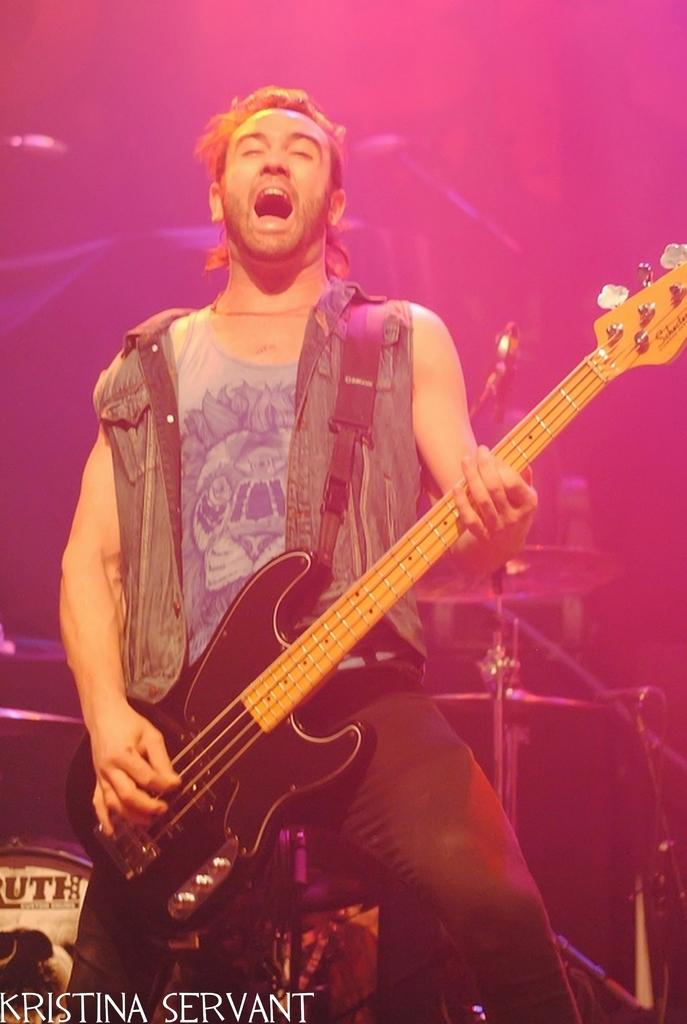What is the main subject in the foreground of the image? There is a man in the foreground of the image. What is the man doing in the image? The man is standing and playing a guitar. What can be seen in the background of the image? In the background, there is pink light, drums, and mic stands. What type of flesh can be seen on the bee in the image? There is no bee present in the image, so there is no flesh to observe. 